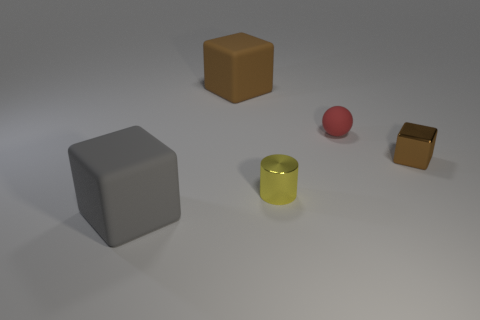What number of other objects are there of the same size as the yellow cylinder?
Give a very brief answer. 2. There is a rubber cube to the right of the gray rubber thing; does it have the same size as the brown object right of the red object?
Ensure brevity in your answer.  No. How many objects are tiny yellow shiny cylinders or rubber objects in front of the brown shiny block?
Provide a short and direct response. 2. There is a rubber block that is right of the gray thing; what size is it?
Give a very brief answer. Large. Are there fewer big cubes that are on the right side of the big brown object than cubes that are in front of the tiny shiny cylinder?
Make the answer very short. Yes. The cube that is both in front of the tiny rubber sphere and on the left side of the yellow metal thing is made of what material?
Your response must be concise. Rubber. What shape is the matte object that is right of the big block behind the small brown shiny block?
Keep it short and to the point. Sphere. How many red things are either small metallic cylinders or tiny balls?
Keep it short and to the point. 1. There is a gray block; are there any matte cubes in front of it?
Offer a very short reply. No. What size is the metal block?
Your answer should be very brief. Small. 